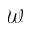Convert formula to latex. <formula><loc_0><loc_0><loc_500><loc_500>\mathcal { W }</formula> 